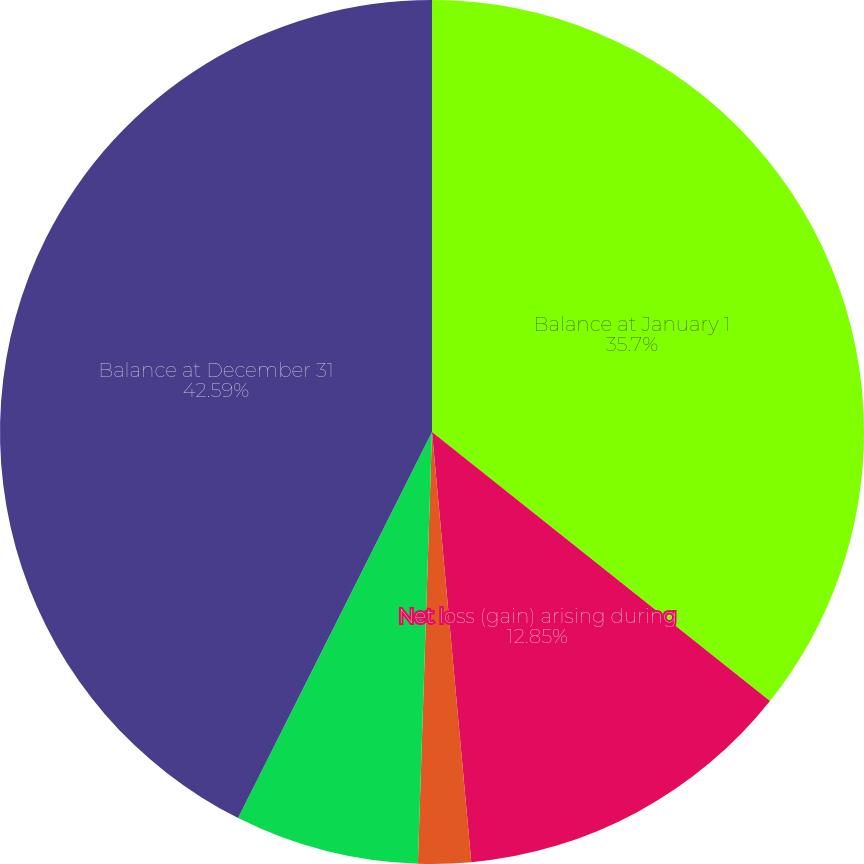Convert chart to OTSL. <chart><loc_0><loc_0><loc_500><loc_500><pie_chart><fcel>Balance at January 1<fcel>Net loss (gain) arising during<fcel>Less amounts included in<fcel>Net change for the year<fcel>Balance at December 31<nl><fcel>35.7%<fcel>12.85%<fcel>1.97%<fcel>6.89%<fcel>42.59%<nl></chart> 